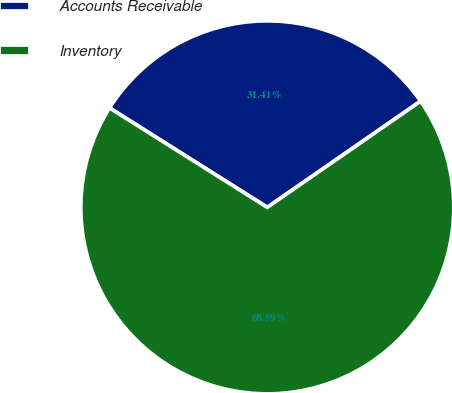Convert chart to OTSL. <chart><loc_0><loc_0><loc_500><loc_500><pie_chart><fcel>Accounts Receivable<fcel>Inventory<nl><fcel>31.41%<fcel>68.59%<nl></chart> 